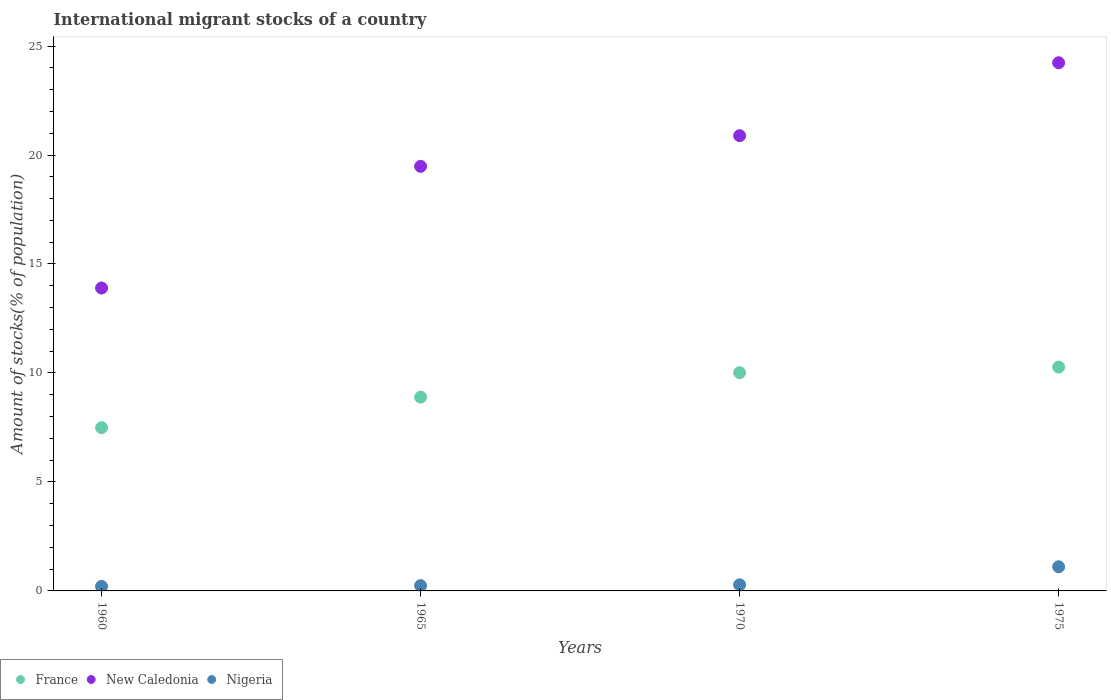How many different coloured dotlines are there?
Keep it short and to the point. 3. Is the number of dotlines equal to the number of legend labels?
Make the answer very short. Yes. What is the amount of stocks in in New Caledonia in 1975?
Ensure brevity in your answer.  24.23. Across all years, what is the maximum amount of stocks in in New Caledonia?
Your answer should be compact. 24.23. Across all years, what is the minimum amount of stocks in in Nigeria?
Provide a short and direct response. 0.21. In which year was the amount of stocks in in Nigeria maximum?
Ensure brevity in your answer.  1975. In which year was the amount of stocks in in Nigeria minimum?
Ensure brevity in your answer.  1960. What is the total amount of stocks in in Nigeria in the graph?
Provide a succinct answer. 1.84. What is the difference between the amount of stocks in in France in 1960 and that in 1965?
Make the answer very short. -1.4. What is the difference between the amount of stocks in in France in 1970 and the amount of stocks in in New Caledonia in 1965?
Keep it short and to the point. -9.47. What is the average amount of stocks in in New Caledonia per year?
Your answer should be very brief. 19.62. In the year 1975, what is the difference between the amount of stocks in in France and amount of stocks in in New Caledonia?
Your answer should be compact. -13.96. What is the ratio of the amount of stocks in in France in 1965 to that in 1970?
Ensure brevity in your answer.  0.89. What is the difference between the highest and the second highest amount of stocks in in France?
Offer a very short reply. 0.26. What is the difference between the highest and the lowest amount of stocks in in France?
Keep it short and to the point. 2.78. Does the amount of stocks in in New Caledonia monotonically increase over the years?
Your answer should be compact. Yes. Is the amount of stocks in in Nigeria strictly less than the amount of stocks in in France over the years?
Make the answer very short. Yes. How many dotlines are there?
Offer a very short reply. 3. What is the difference between two consecutive major ticks on the Y-axis?
Provide a short and direct response. 5. Are the values on the major ticks of Y-axis written in scientific E-notation?
Your response must be concise. No. Does the graph contain any zero values?
Provide a succinct answer. No. Where does the legend appear in the graph?
Your response must be concise. Bottom left. What is the title of the graph?
Offer a terse response. International migrant stocks of a country. Does "United Arab Emirates" appear as one of the legend labels in the graph?
Make the answer very short. No. What is the label or title of the X-axis?
Make the answer very short. Years. What is the label or title of the Y-axis?
Provide a succinct answer. Amount of stocks(% of population). What is the Amount of stocks(% of population) in France in 1960?
Offer a very short reply. 7.49. What is the Amount of stocks(% of population) in New Caledonia in 1960?
Ensure brevity in your answer.  13.9. What is the Amount of stocks(% of population) in Nigeria in 1960?
Ensure brevity in your answer.  0.21. What is the Amount of stocks(% of population) of France in 1965?
Your answer should be very brief. 8.89. What is the Amount of stocks(% of population) of New Caledonia in 1965?
Your response must be concise. 19.48. What is the Amount of stocks(% of population) in Nigeria in 1965?
Provide a succinct answer. 0.24. What is the Amount of stocks(% of population) in France in 1970?
Give a very brief answer. 10.01. What is the Amount of stocks(% of population) in New Caledonia in 1970?
Your response must be concise. 20.89. What is the Amount of stocks(% of population) in Nigeria in 1970?
Your response must be concise. 0.28. What is the Amount of stocks(% of population) of France in 1975?
Your response must be concise. 10.27. What is the Amount of stocks(% of population) of New Caledonia in 1975?
Provide a succinct answer. 24.23. What is the Amount of stocks(% of population) of Nigeria in 1975?
Offer a terse response. 1.11. Across all years, what is the maximum Amount of stocks(% of population) in France?
Your answer should be compact. 10.27. Across all years, what is the maximum Amount of stocks(% of population) in New Caledonia?
Keep it short and to the point. 24.23. Across all years, what is the maximum Amount of stocks(% of population) of Nigeria?
Make the answer very short. 1.11. Across all years, what is the minimum Amount of stocks(% of population) in France?
Provide a short and direct response. 7.49. Across all years, what is the minimum Amount of stocks(% of population) of New Caledonia?
Keep it short and to the point. 13.9. Across all years, what is the minimum Amount of stocks(% of population) in Nigeria?
Your answer should be very brief. 0.21. What is the total Amount of stocks(% of population) of France in the graph?
Your response must be concise. 36.66. What is the total Amount of stocks(% of population) of New Caledonia in the graph?
Offer a terse response. 78.5. What is the total Amount of stocks(% of population) in Nigeria in the graph?
Offer a very short reply. 1.84. What is the difference between the Amount of stocks(% of population) of France in 1960 and that in 1965?
Your answer should be compact. -1.4. What is the difference between the Amount of stocks(% of population) in New Caledonia in 1960 and that in 1965?
Provide a short and direct response. -5.58. What is the difference between the Amount of stocks(% of population) in Nigeria in 1960 and that in 1965?
Keep it short and to the point. -0.03. What is the difference between the Amount of stocks(% of population) of France in 1960 and that in 1970?
Give a very brief answer. -2.52. What is the difference between the Amount of stocks(% of population) in New Caledonia in 1960 and that in 1970?
Your response must be concise. -6.99. What is the difference between the Amount of stocks(% of population) of Nigeria in 1960 and that in 1970?
Keep it short and to the point. -0.07. What is the difference between the Amount of stocks(% of population) of France in 1960 and that in 1975?
Your answer should be compact. -2.78. What is the difference between the Amount of stocks(% of population) in New Caledonia in 1960 and that in 1975?
Offer a terse response. -10.34. What is the difference between the Amount of stocks(% of population) of Nigeria in 1960 and that in 1975?
Offer a terse response. -0.9. What is the difference between the Amount of stocks(% of population) of France in 1965 and that in 1970?
Your response must be concise. -1.12. What is the difference between the Amount of stocks(% of population) in New Caledonia in 1965 and that in 1970?
Offer a very short reply. -1.41. What is the difference between the Amount of stocks(% of population) of Nigeria in 1965 and that in 1970?
Provide a short and direct response. -0.04. What is the difference between the Amount of stocks(% of population) in France in 1965 and that in 1975?
Keep it short and to the point. -1.38. What is the difference between the Amount of stocks(% of population) in New Caledonia in 1965 and that in 1975?
Your answer should be compact. -4.75. What is the difference between the Amount of stocks(% of population) of Nigeria in 1965 and that in 1975?
Provide a short and direct response. -0.87. What is the difference between the Amount of stocks(% of population) of France in 1970 and that in 1975?
Ensure brevity in your answer.  -0.26. What is the difference between the Amount of stocks(% of population) in New Caledonia in 1970 and that in 1975?
Keep it short and to the point. -3.35. What is the difference between the Amount of stocks(% of population) in Nigeria in 1970 and that in 1975?
Give a very brief answer. -0.83. What is the difference between the Amount of stocks(% of population) of France in 1960 and the Amount of stocks(% of population) of New Caledonia in 1965?
Your answer should be compact. -11.99. What is the difference between the Amount of stocks(% of population) of France in 1960 and the Amount of stocks(% of population) of Nigeria in 1965?
Your answer should be compact. 7.25. What is the difference between the Amount of stocks(% of population) of New Caledonia in 1960 and the Amount of stocks(% of population) of Nigeria in 1965?
Your answer should be very brief. 13.65. What is the difference between the Amount of stocks(% of population) in France in 1960 and the Amount of stocks(% of population) in New Caledonia in 1970?
Provide a succinct answer. -13.39. What is the difference between the Amount of stocks(% of population) in France in 1960 and the Amount of stocks(% of population) in Nigeria in 1970?
Offer a terse response. 7.21. What is the difference between the Amount of stocks(% of population) in New Caledonia in 1960 and the Amount of stocks(% of population) in Nigeria in 1970?
Your response must be concise. 13.62. What is the difference between the Amount of stocks(% of population) in France in 1960 and the Amount of stocks(% of population) in New Caledonia in 1975?
Ensure brevity in your answer.  -16.74. What is the difference between the Amount of stocks(% of population) of France in 1960 and the Amount of stocks(% of population) of Nigeria in 1975?
Your answer should be very brief. 6.38. What is the difference between the Amount of stocks(% of population) of New Caledonia in 1960 and the Amount of stocks(% of population) of Nigeria in 1975?
Offer a very short reply. 12.79. What is the difference between the Amount of stocks(% of population) in France in 1965 and the Amount of stocks(% of population) in New Caledonia in 1970?
Offer a very short reply. -12. What is the difference between the Amount of stocks(% of population) of France in 1965 and the Amount of stocks(% of population) of Nigeria in 1970?
Your answer should be very brief. 8.61. What is the difference between the Amount of stocks(% of population) in New Caledonia in 1965 and the Amount of stocks(% of population) in Nigeria in 1970?
Offer a very short reply. 19.2. What is the difference between the Amount of stocks(% of population) of France in 1965 and the Amount of stocks(% of population) of New Caledonia in 1975?
Keep it short and to the point. -15.34. What is the difference between the Amount of stocks(% of population) of France in 1965 and the Amount of stocks(% of population) of Nigeria in 1975?
Make the answer very short. 7.78. What is the difference between the Amount of stocks(% of population) in New Caledonia in 1965 and the Amount of stocks(% of population) in Nigeria in 1975?
Provide a succinct answer. 18.37. What is the difference between the Amount of stocks(% of population) in France in 1970 and the Amount of stocks(% of population) in New Caledonia in 1975?
Keep it short and to the point. -14.22. What is the difference between the Amount of stocks(% of population) in France in 1970 and the Amount of stocks(% of population) in Nigeria in 1975?
Your response must be concise. 8.9. What is the difference between the Amount of stocks(% of population) in New Caledonia in 1970 and the Amount of stocks(% of population) in Nigeria in 1975?
Offer a terse response. 19.78. What is the average Amount of stocks(% of population) in France per year?
Give a very brief answer. 9.17. What is the average Amount of stocks(% of population) of New Caledonia per year?
Your answer should be very brief. 19.62. What is the average Amount of stocks(% of population) in Nigeria per year?
Ensure brevity in your answer.  0.46. In the year 1960, what is the difference between the Amount of stocks(% of population) in France and Amount of stocks(% of population) in New Caledonia?
Your answer should be compact. -6.41. In the year 1960, what is the difference between the Amount of stocks(% of population) of France and Amount of stocks(% of population) of Nigeria?
Your answer should be very brief. 7.28. In the year 1960, what is the difference between the Amount of stocks(% of population) in New Caledonia and Amount of stocks(% of population) in Nigeria?
Ensure brevity in your answer.  13.69. In the year 1965, what is the difference between the Amount of stocks(% of population) in France and Amount of stocks(% of population) in New Caledonia?
Your response must be concise. -10.59. In the year 1965, what is the difference between the Amount of stocks(% of population) in France and Amount of stocks(% of population) in Nigeria?
Offer a terse response. 8.65. In the year 1965, what is the difference between the Amount of stocks(% of population) of New Caledonia and Amount of stocks(% of population) of Nigeria?
Offer a terse response. 19.24. In the year 1970, what is the difference between the Amount of stocks(% of population) in France and Amount of stocks(% of population) in New Caledonia?
Your answer should be very brief. -10.87. In the year 1970, what is the difference between the Amount of stocks(% of population) of France and Amount of stocks(% of population) of Nigeria?
Offer a terse response. 9.73. In the year 1970, what is the difference between the Amount of stocks(% of population) of New Caledonia and Amount of stocks(% of population) of Nigeria?
Provide a short and direct response. 20.6. In the year 1975, what is the difference between the Amount of stocks(% of population) in France and Amount of stocks(% of population) in New Caledonia?
Ensure brevity in your answer.  -13.96. In the year 1975, what is the difference between the Amount of stocks(% of population) of France and Amount of stocks(% of population) of Nigeria?
Your answer should be very brief. 9.16. In the year 1975, what is the difference between the Amount of stocks(% of population) of New Caledonia and Amount of stocks(% of population) of Nigeria?
Your answer should be compact. 23.12. What is the ratio of the Amount of stocks(% of population) of France in 1960 to that in 1965?
Keep it short and to the point. 0.84. What is the ratio of the Amount of stocks(% of population) in New Caledonia in 1960 to that in 1965?
Give a very brief answer. 0.71. What is the ratio of the Amount of stocks(% of population) in Nigeria in 1960 to that in 1965?
Provide a succinct answer. 0.86. What is the ratio of the Amount of stocks(% of population) of France in 1960 to that in 1970?
Your response must be concise. 0.75. What is the ratio of the Amount of stocks(% of population) of New Caledonia in 1960 to that in 1970?
Keep it short and to the point. 0.67. What is the ratio of the Amount of stocks(% of population) in Nigeria in 1960 to that in 1970?
Provide a succinct answer. 0.74. What is the ratio of the Amount of stocks(% of population) in France in 1960 to that in 1975?
Your answer should be compact. 0.73. What is the ratio of the Amount of stocks(% of population) in New Caledonia in 1960 to that in 1975?
Make the answer very short. 0.57. What is the ratio of the Amount of stocks(% of population) in Nigeria in 1960 to that in 1975?
Your answer should be very brief. 0.19. What is the ratio of the Amount of stocks(% of population) in France in 1965 to that in 1970?
Provide a short and direct response. 0.89. What is the ratio of the Amount of stocks(% of population) in New Caledonia in 1965 to that in 1970?
Your response must be concise. 0.93. What is the ratio of the Amount of stocks(% of population) of Nigeria in 1965 to that in 1970?
Your answer should be compact. 0.86. What is the ratio of the Amount of stocks(% of population) in France in 1965 to that in 1975?
Your response must be concise. 0.87. What is the ratio of the Amount of stocks(% of population) of New Caledonia in 1965 to that in 1975?
Offer a very short reply. 0.8. What is the ratio of the Amount of stocks(% of population) in Nigeria in 1965 to that in 1975?
Provide a succinct answer. 0.22. What is the ratio of the Amount of stocks(% of population) of France in 1970 to that in 1975?
Your answer should be very brief. 0.97. What is the ratio of the Amount of stocks(% of population) of New Caledonia in 1970 to that in 1975?
Your answer should be very brief. 0.86. What is the ratio of the Amount of stocks(% of population) of Nigeria in 1970 to that in 1975?
Keep it short and to the point. 0.25. What is the difference between the highest and the second highest Amount of stocks(% of population) of France?
Ensure brevity in your answer.  0.26. What is the difference between the highest and the second highest Amount of stocks(% of population) of New Caledonia?
Make the answer very short. 3.35. What is the difference between the highest and the second highest Amount of stocks(% of population) in Nigeria?
Give a very brief answer. 0.83. What is the difference between the highest and the lowest Amount of stocks(% of population) in France?
Give a very brief answer. 2.78. What is the difference between the highest and the lowest Amount of stocks(% of population) in New Caledonia?
Your answer should be very brief. 10.34. What is the difference between the highest and the lowest Amount of stocks(% of population) in Nigeria?
Provide a short and direct response. 0.9. 